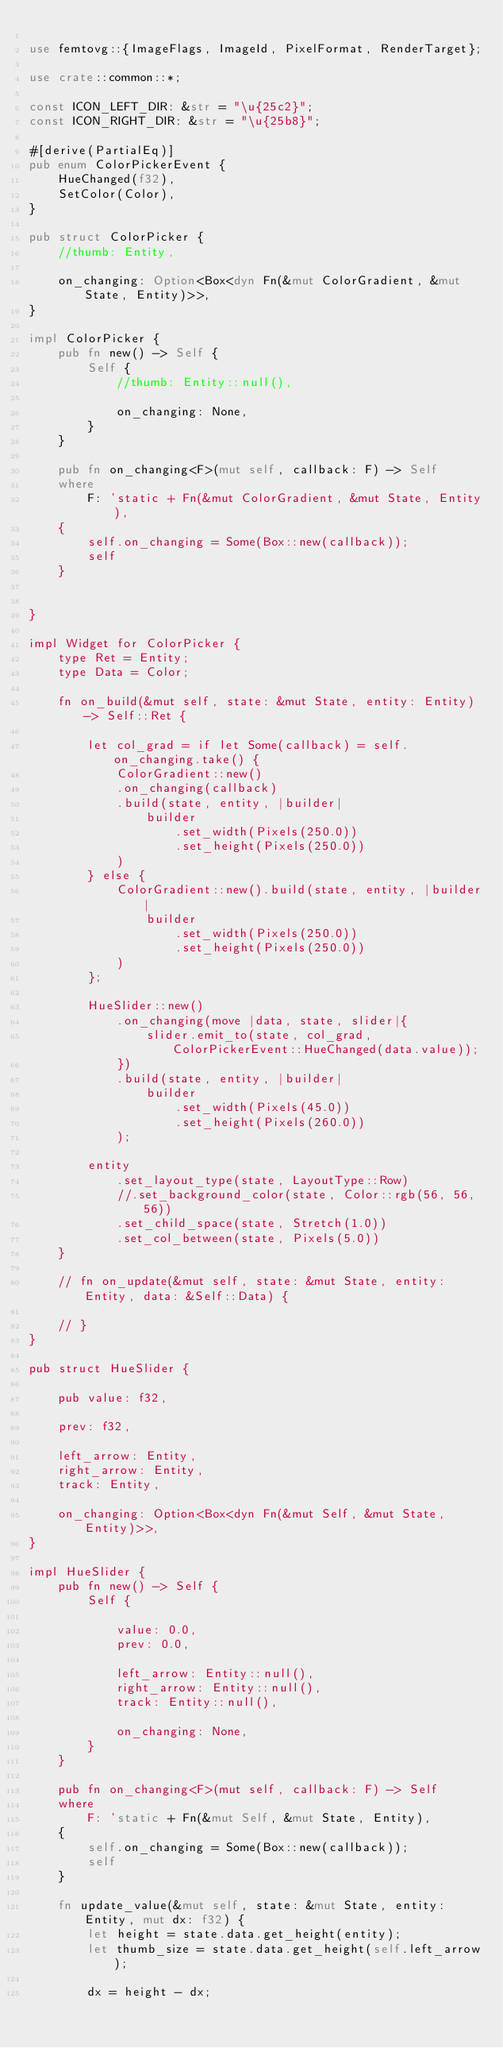Convert code to text. <code><loc_0><loc_0><loc_500><loc_500><_Rust_>
use femtovg::{ImageFlags, ImageId, PixelFormat, RenderTarget};

use crate::common::*;

const ICON_LEFT_DIR: &str = "\u{25c2}";
const ICON_RIGHT_DIR: &str = "\u{25b8}";

#[derive(PartialEq)]
pub enum ColorPickerEvent {
    HueChanged(f32),
    SetColor(Color),
}

pub struct ColorPicker {
    //thumb: Entity,

    on_changing: Option<Box<dyn Fn(&mut ColorGradient, &mut State, Entity)>>,
}

impl ColorPicker {
    pub fn new() -> Self {
        Self {
            //thumb: Entity::null(),

            on_changing: None,
        }
    }

    pub fn on_changing<F>(mut self, callback: F) -> Self
    where
        F: 'static + Fn(&mut ColorGradient, &mut State, Entity),
    {
        self.on_changing = Some(Box::new(callback));
        self
    }


}

impl Widget for ColorPicker {
    type Ret = Entity;
    type Data = Color;

    fn on_build(&mut self, state: &mut State, entity: Entity) -> Self::Ret {

        let col_grad = if let Some(callback) = self.on_changing.take() {
            ColorGradient::new()
            .on_changing(callback)
            .build(state, entity, |builder|
                builder
                    .set_width(Pixels(250.0))
                    .set_height(Pixels(250.0))
            )
        } else {
            ColorGradient::new().build(state, entity, |builder|
                builder
                    .set_width(Pixels(250.0))
                    .set_height(Pixels(250.0))
            )
        };

        HueSlider::new()
            .on_changing(move |data, state, slider|{
                slider.emit_to(state, col_grad, ColorPickerEvent::HueChanged(data.value));
            })
            .build(state, entity, |builder|
                builder
                    .set_width(Pixels(45.0))
                    .set_height(Pixels(260.0))
            );

        entity
            .set_layout_type(state, LayoutType::Row)
            //.set_background_color(state, Color::rgb(56, 56, 56))
            .set_child_space(state, Stretch(1.0))
            .set_col_between(state, Pixels(5.0))
    }

    // fn on_update(&mut self, state: &mut State, entity: Entity, data: &Self::Data) {
        
    // }
}

pub struct HueSlider {

    pub value: f32,

    prev: f32,

    left_arrow: Entity,
    right_arrow: Entity,
    track: Entity,

    on_changing: Option<Box<dyn Fn(&mut Self, &mut State, Entity)>>,
}

impl HueSlider {
    pub fn new() -> Self {
        Self {

            value: 0.0,
            prev: 0.0,

            left_arrow: Entity::null(),
            right_arrow: Entity::null(),
            track: Entity::null(),

            on_changing: None,
        }
    }

    pub fn on_changing<F>(mut self, callback: F) -> Self
    where
        F: 'static + Fn(&mut Self, &mut State, Entity),
    {
        self.on_changing = Some(Box::new(callback));
        self
    }

    fn update_value(&mut self, state: &mut State, entity: Entity, mut dx: f32) {
        let height = state.data.get_height(entity);
        let thumb_size = state.data.get_height(self.left_arrow);

        dx = height - dx;
</code> 